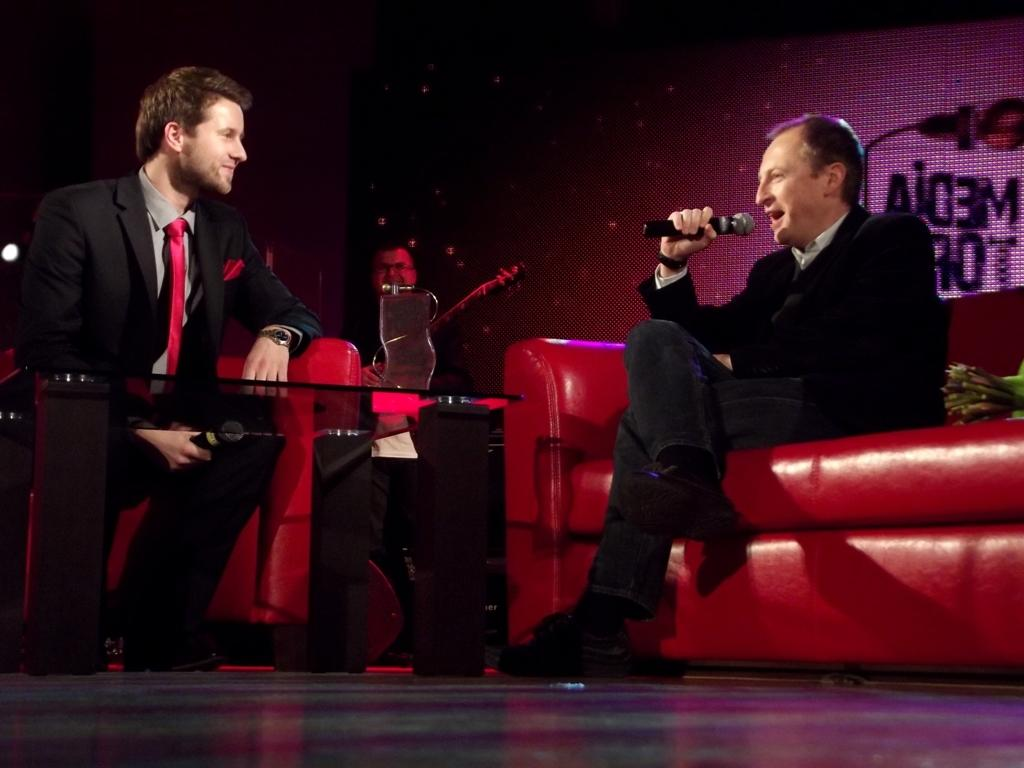How many people are in the image? There are people in the image. What are the seated people doing in the image? Two people are seated on sofas and holding microphones. What object is on the table in front of the seated people? There is a shield on a table in front of the seated people. What type of wound can be seen on the person standing next to the shield? There is no person standing next to the shield in the image. Are there any boats visible in the image? There are no boats present in the image. 